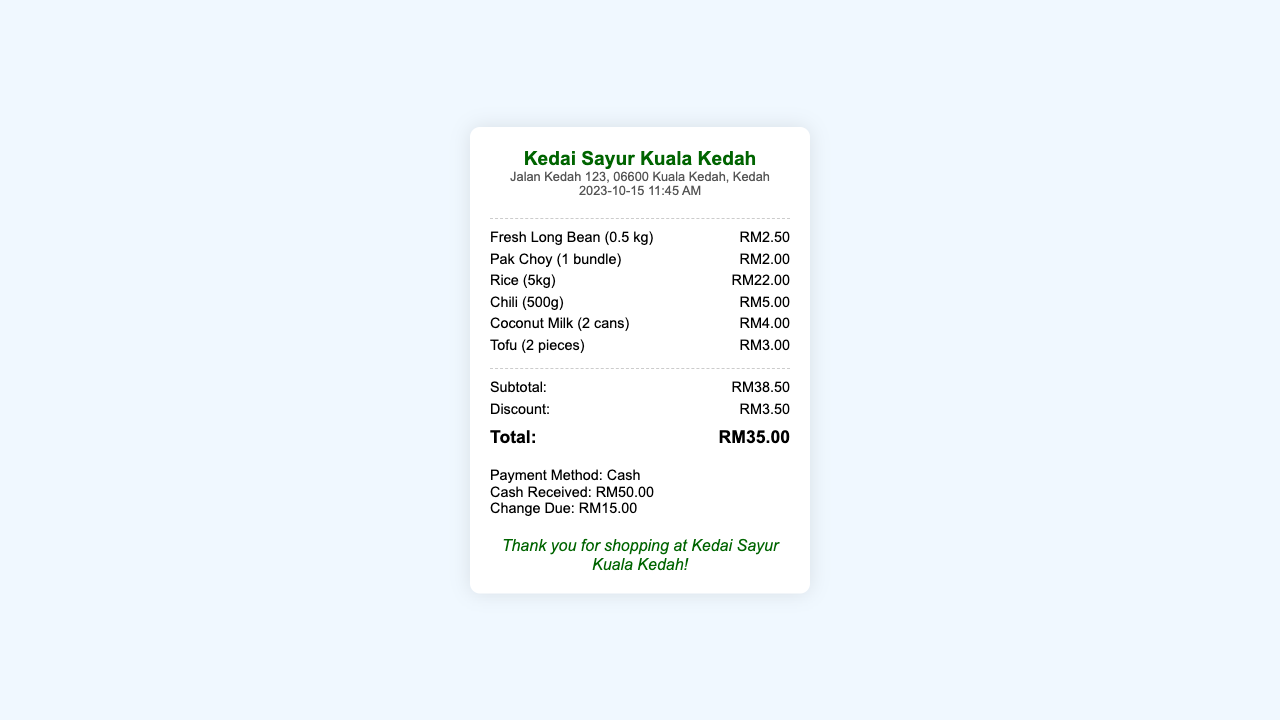What is the date of the receipt? The date of the receipt is found in the document under the date-time section.
Answer: 2023-10-15 What is the name of the store? The store name is prominently displayed at the top of the receipt.
Answer: Kedai Sayur Kuala Kedah How much did the Fresh Long Bean cost? The price for Fresh Long Bean is listed under the items section of the receipt.
Answer: RM2.50 What was the subtotal amount? The subtotal amount is calculated from all items before any discounts are applied, as shown in the totals section.
Answer: RM38.50 What discount was applied? The discount amount is clearly stated in the totals section of the receipt.
Answer: RM3.50 What is the total amount due after discount? The total amount due is found in the totals section and represents the final amount after applying the discount.
Answer: RM35.00 How much cash was received? The amount of cash received is noted in the payment information section of the receipt.
Answer: RM50.00 How much change is due? The change due is indicated in the payment information section of the receipt after the total is deducted from the cash received.
Answer: RM15.00 What items were purchased? The items purchased are listed individually in the items section of the receipt.
Answer: Fresh Long Bean, Pak Choy, Rice, Chili, Coconut Milk, Tofu 